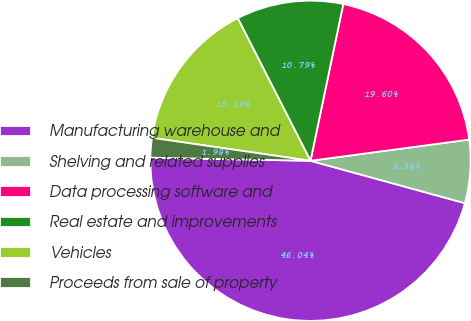Convert chart to OTSL. <chart><loc_0><loc_0><loc_500><loc_500><pie_chart><fcel>Manufacturing warehouse and<fcel>Shelving and related supplies<fcel>Data processing software and<fcel>Real estate and improvements<fcel>Vehicles<fcel>Proceeds from sale of property<nl><fcel>46.04%<fcel>6.38%<fcel>19.6%<fcel>10.79%<fcel>15.2%<fcel>1.98%<nl></chart> 